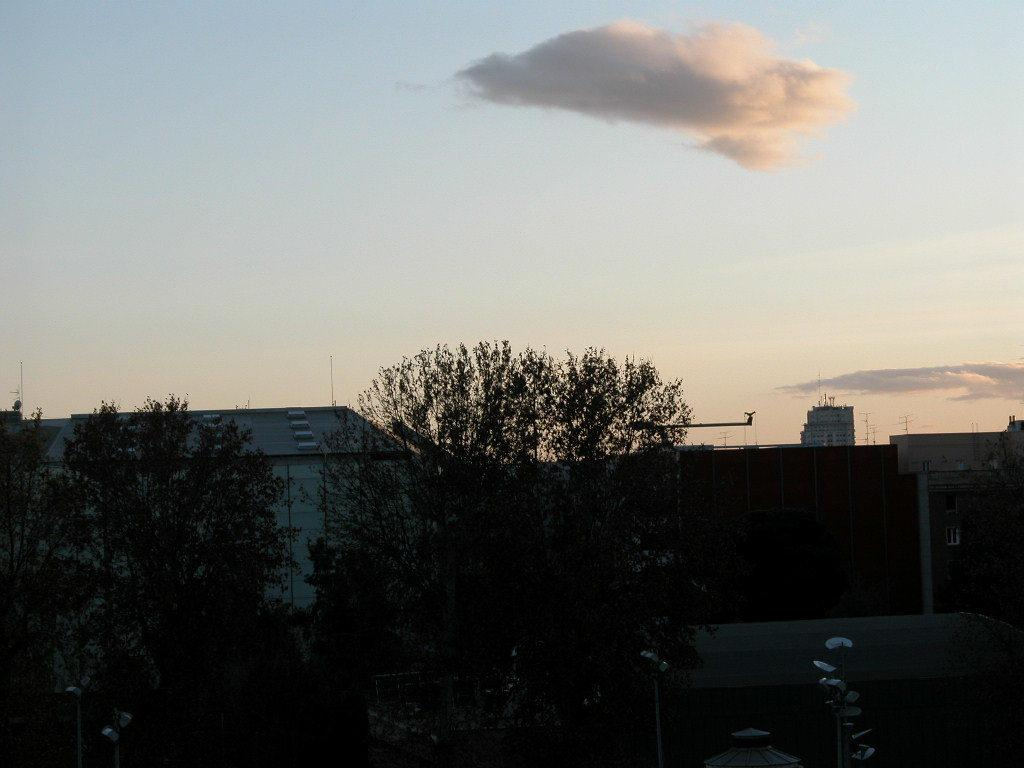What type of natural elements can be seen in the image? There are trees in the image. What type of man-made structures can be seen in the image? There are buildings in the image. What is located near the trees in the image? There are objects near the trees in the image. What can be seen in the background of the image? The sky is visible in the background of the image. What is the condition of the sky in the image? Clouds are present in the sky. Can you tell me how much sugar is in the garden in the image? There is no garden or sugar present in the image; it features trees, buildings, and objects near the trees. 